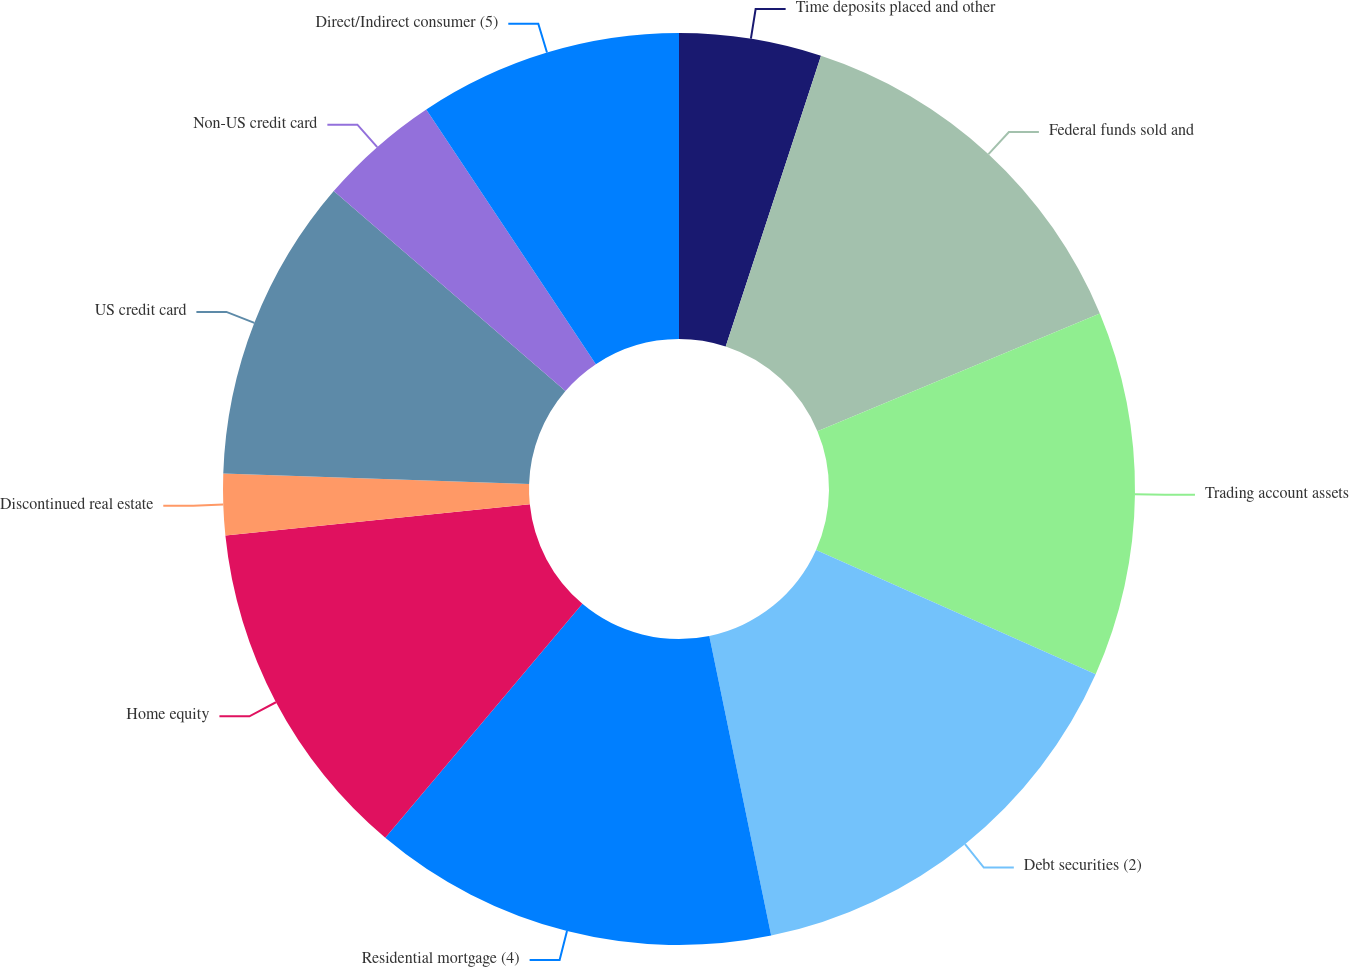Convert chart. <chart><loc_0><loc_0><loc_500><loc_500><pie_chart><fcel>Time deposits placed and other<fcel>Federal funds sold and<fcel>Trading account assets<fcel>Debt securities (2)<fcel>Residential mortgage (4)<fcel>Home equity<fcel>Discontinued real estate<fcel>US credit card<fcel>Non-US credit card<fcel>Direct/Indirect consumer (5)<nl><fcel>5.04%<fcel>13.67%<fcel>12.95%<fcel>15.1%<fcel>14.38%<fcel>12.23%<fcel>2.17%<fcel>10.79%<fcel>4.32%<fcel>9.35%<nl></chart> 